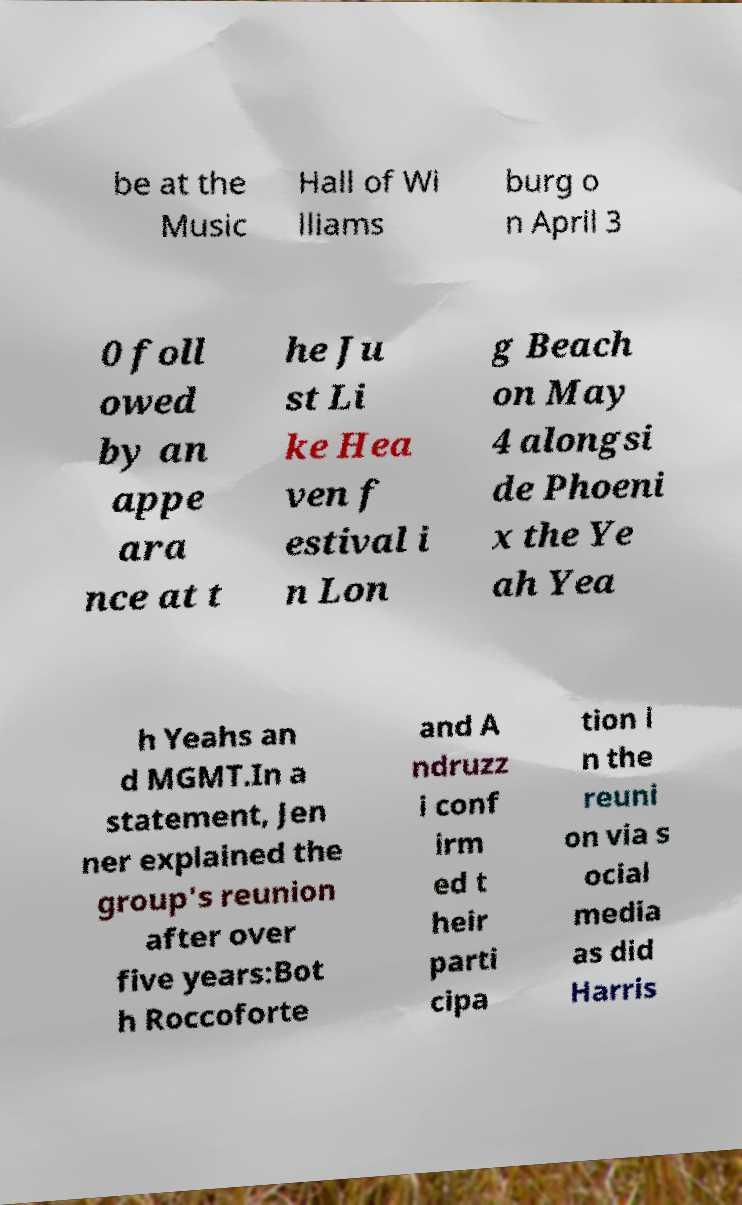For documentation purposes, I need the text within this image transcribed. Could you provide that? be at the Music Hall of Wi lliams burg o n April 3 0 foll owed by an appe ara nce at t he Ju st Li ke Hea ven f estival i n Lon g Beach on May 4 alongsi de Phoeni x the Ye ah Yea h Yeahs an d MGMT.In a statement, Jen ner explained the group's reunion after over five years:Bot h Roccoforte and A ndruzz i conf irm ed t heir parti cipa tion i n the reuni on via s ocial media as did Harris 